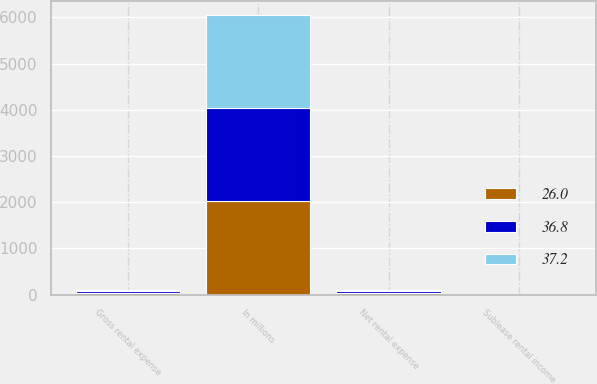Convert chart. <chart><loc_0><loc_0><loc_500><loc_500><stacked_bar_chart><ecel><fcel>In millions<fcel>Gross rental expense<fcel>Sublease rental income<fcel>Net rental expense<nl><fcel>26<fcel>2016<fcel>37.5<fcel>0.7<fcel>36.8<nl><fcel>37.2<fcel>2015<fcel>26.4<fcel>0.4<fcel>26<nl><fcel>36.8<fcel>2014<fcel>38.2<fcel>1<fcel>37.2<nl></chart> 